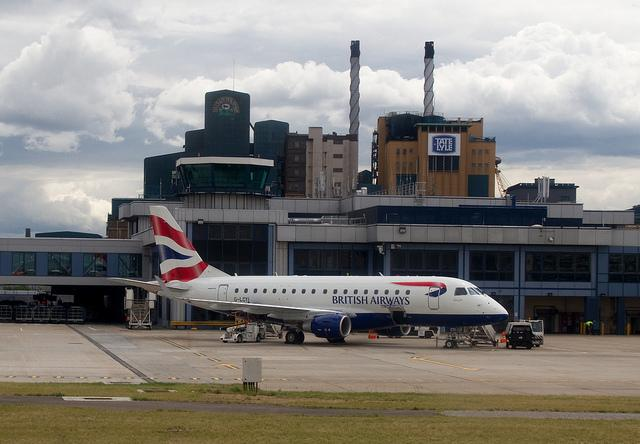What is placed in the underneath of a plane storage? Please explain your reasoning. luggage. Luggage is loaded into the bottom of planes. vehicles are parked nbear a plane at an airport. 